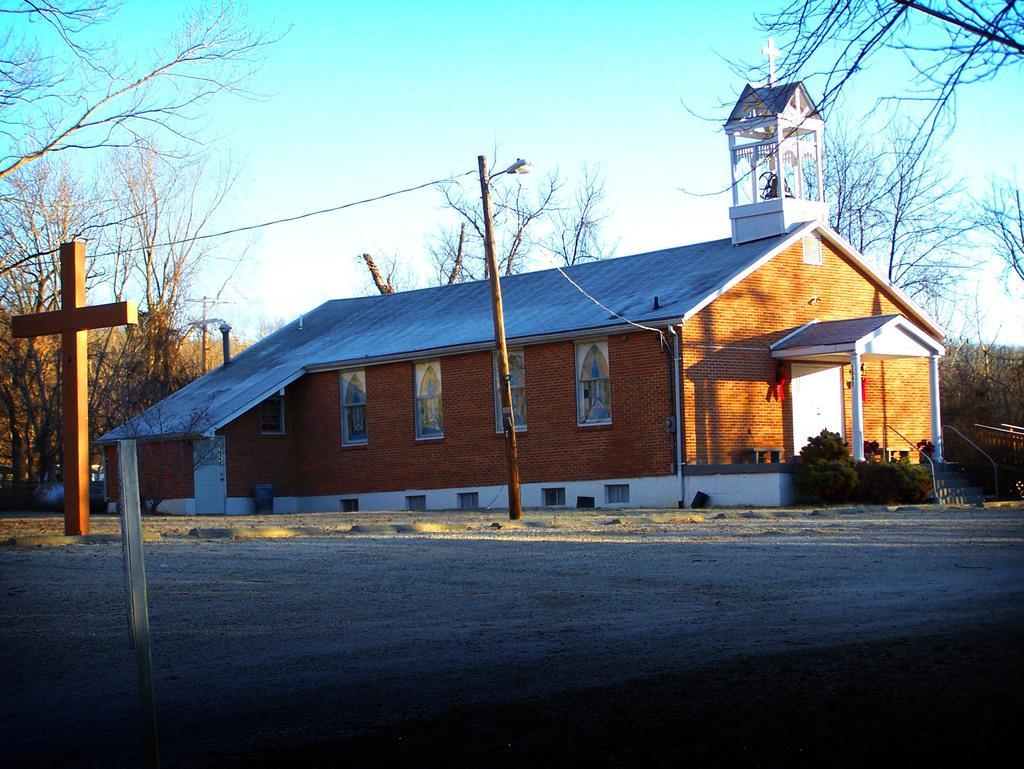How would you summarize this image in a sentence or two? In this image we can see the church and on the left side of the image we can see the cross. There is a road and to the side, we can see a street light and we can see some plants and trees and at the top we can see the sky. 